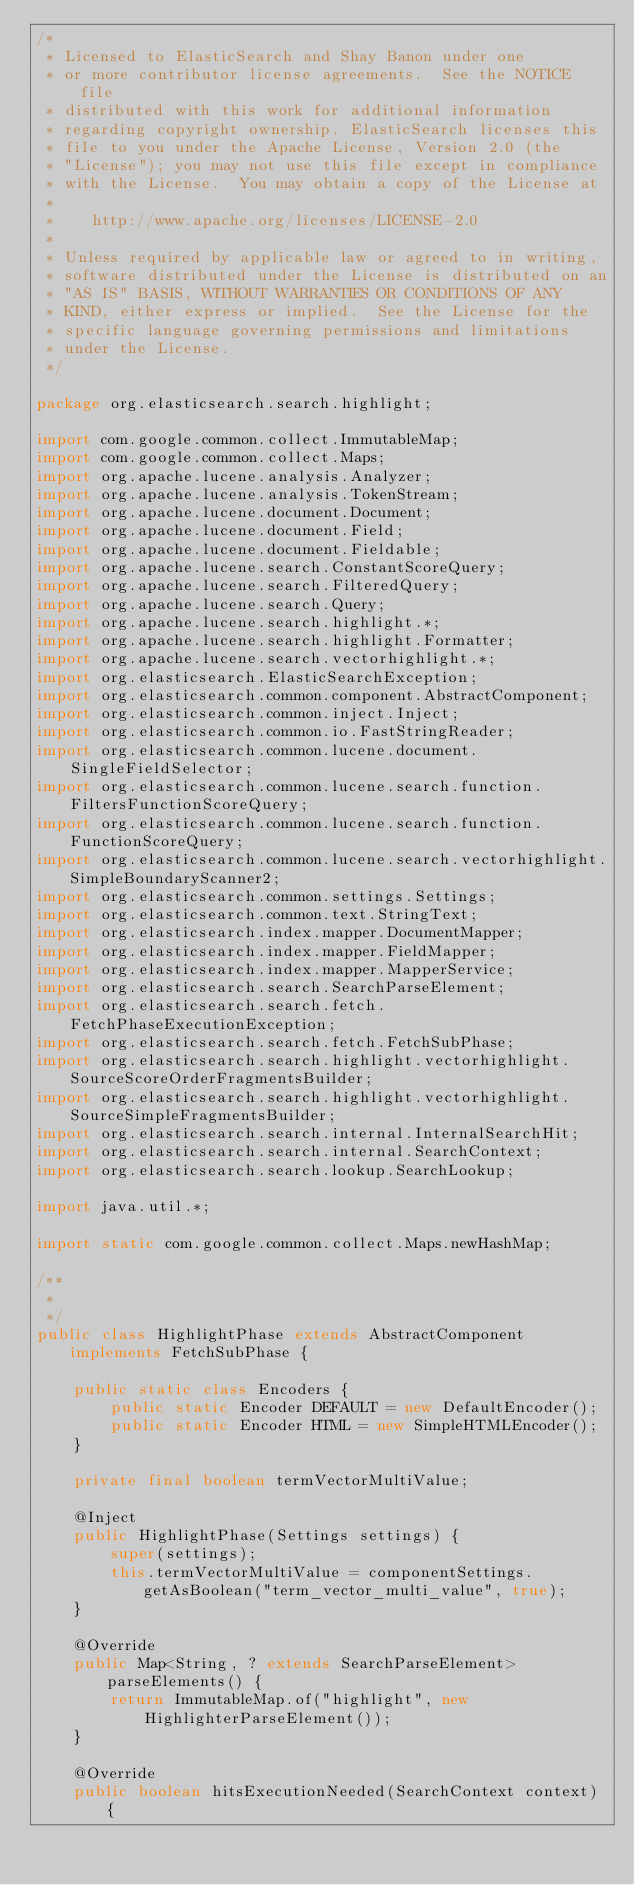Convert code to text. <code><loc_0><loc_0><loc_500><loc_500><_Java_>/*
 * Licensed to ElasticSearch and Shay Banon under one
 * or more contributor license agreements.  See the NOTICE file
 * distributed with this work for additional information
 * regarding copyright ownership. ElasticSearch licenses this
 * file to you under the Apache License, Version 2.0 (the
 * "License"); you may not use this file except in compliance
 * with the License.  You may obtain a copy of the License at
 *
 *    http://www.apache.org/licenses/LICENSE-2.0
 *
 * Unless required by applicable law or agreed to in writing,
 * software distributed under the License is distributed on an
 * "AS IS" BASIS, WITHOUT WARRANTIES OR CONDITIONS OF ANY
 * KIND, either express or implied.  See the License for the
 * specific language governing permissions and limitations
 * under the License.
 */

package org.elasticsearch.search.highlight;

import com.google.common.collect.ImmutableMap;
import com.google.common.collect.Maps;
import org.apache.lucene.analysis.Analyzer;
import org.apache.lucene.analysis.TokenStream;
import org.apache.lucene.document.Document;
import org.apache.lucene.document.Field;
import org.apache.lucene.document.Fieldable;
import org.apache.lucene.search.ConstantScoreQuery;
import org.apache.lucene.search.FilteredQuery;
import org.apache.lucene.search.Query;
import org.apache.lucene.search.highlight.*;
import org.apache.lucene.search.highlight.Formatter;
import org.apache.lucene.search.vectorhighlight.*;
import org.elasticsearch.ElasticSearchException;
import org.elasticsearch.common.component.AbstractComponent;
import org.elasticsearch.common.inject.Inject;
import org.elasticsearch.common.io.FastStringReader;
import org.elasticsearch.common.lucene.document.SingleFieldSelector;
import org.elasticsearch.common.lucene.search.function.FiltersFunctionScoreQuery;
import org.elasticsearch.common.lucene.search.function.FunctionScoreQuery;
import org.elasticsearch.common.lucene.search.vectorhighlight.SimpleBoundaryScanner2;
import org.elasticsearch.common.settings.Settings;
import org.elasticsearch.common.text.StringText;
import org.elasticsearch.index.mapper.DocumentMapper;
import org.elasticsearch.index.mapper.FieldMapper;
import org.elasticsearch.index.mapper.MapperService;
import org.elasticsearch.search.SearchParseElement;
import org.elasticsearch.search.fetch.FetchPhaseExecutionException;
import org.elasticsearch.search.fetch.FetchSubPhase;
import org.elasticsearch.search.highlight.vectorhighlight.SourceScoreOrderFragmentsBuilder;
import org.elasticsearch.search.highlight.vectorhighlight.SourceSimpleFragmentsBuilder;
import org.elasticsearch.search.internal.InternalSearchHit;
import org.elasticsearch.search.internal.SearchContext;
import org.elasticsearch.search.lookup.SearchLookup;

import java.util.*;

import static com.google.common.collect.Maps.newHashMap;

/**
 *
 */
public class HighlightPhase extends AbstractComponent implements FetchSubPhase {

    public static class Encoders {
        public static Encoder DEFAULT = new DefaultEncoder();
        public static Encoder HTML = new SimpleHTMLEncoder();
    }

    private final boolean termVectorMultiValue;

    @Inject
    public HighlightPhase(Settings settings) {
        super(settings);
        this.termVectorMultiValue = componentSettings.getAsBoolean("term_vector_multi_value", true);
    }

    @Override
    public Map<String, ? extends SearchParseElement> parseElements() {
        return ImmutableMap.of("highlight", new HighlighterParseElement());
    }

    @Override
    public boolean hitsExecutionNeeded(SearchContext context) {</code> 